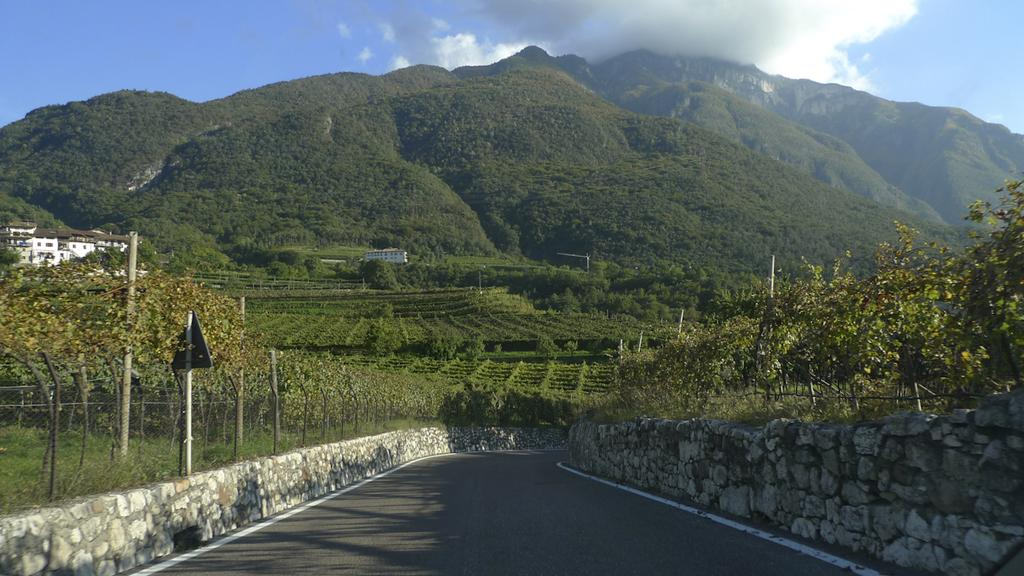What is the main feature of the image? There is a road in the image. What surrounds the road? There are walls made up of rocks around the road. What can be seen behind the walls? There are trees visible behind the walls. How would you describe the natural environment in the background? There is a lot of greenery and mountains visible in the background. What type of coach can be seen driving on the road in the image? There is no coach present in the image; it only shows a road with walls made up of rocks and the surrounding environment. 